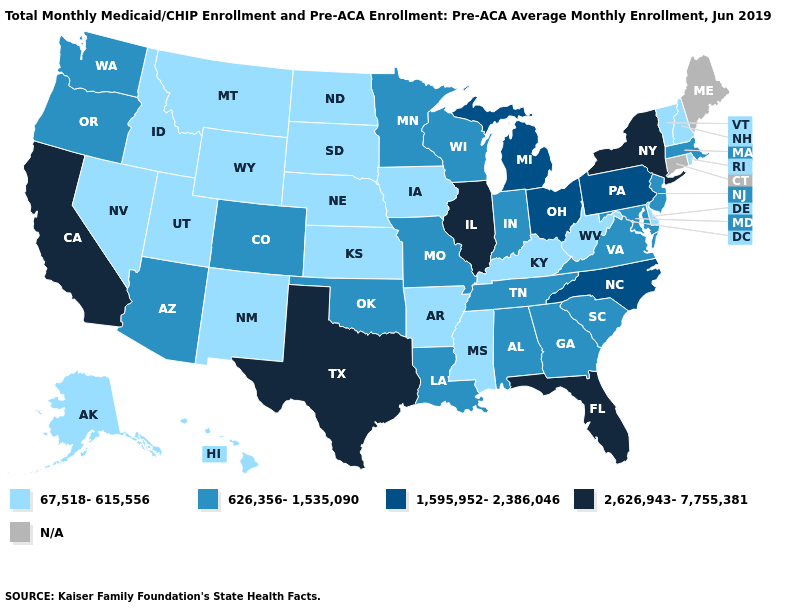Is the legend a continuous bar?
Quick response, please. No. Name the states that have a value in the range 626,356-1,535,090?
Quick response, please. Alabama, Arizona, Colorado, Georgia, Indiana, Louisiana, Maryland, Massachusetts, Minnesota, Missouri, New Jersey, Oklahoma, Oregon, South Carolina, Tennessee, Virginia, Washington, Wisconsin. Does Illinois have the highest value in the MidWest?
Write a very short answer. Yes. What is the value of Wisconsin?
Keep it brief. 626,356-1,535,090. What is the highest value in the MidWest ?
Concise answer only. 2,626,943-7,755,381. What is the value of Connecticut?
Write a very short answer. N/A. Which states have the highest value in the USA?
Give a very brief answer. California, Florida, Illinois, New York, Texas. Name the states that have a value in the range 1,595,952-2,386,046?
Keep it brief. Michigan, North Carolina, Ohio, Pennsylvania. What is the value of Alabama?
Write a very short answer. 626,356-1,535,090. What is the value of Ohio?
Quick response, please. 1,595,952-2,386,046. Which states hav the highest value in the South?
Quick response, please. Florida, Texas. What is the value of Maine?
Answer briefly. N/A. 